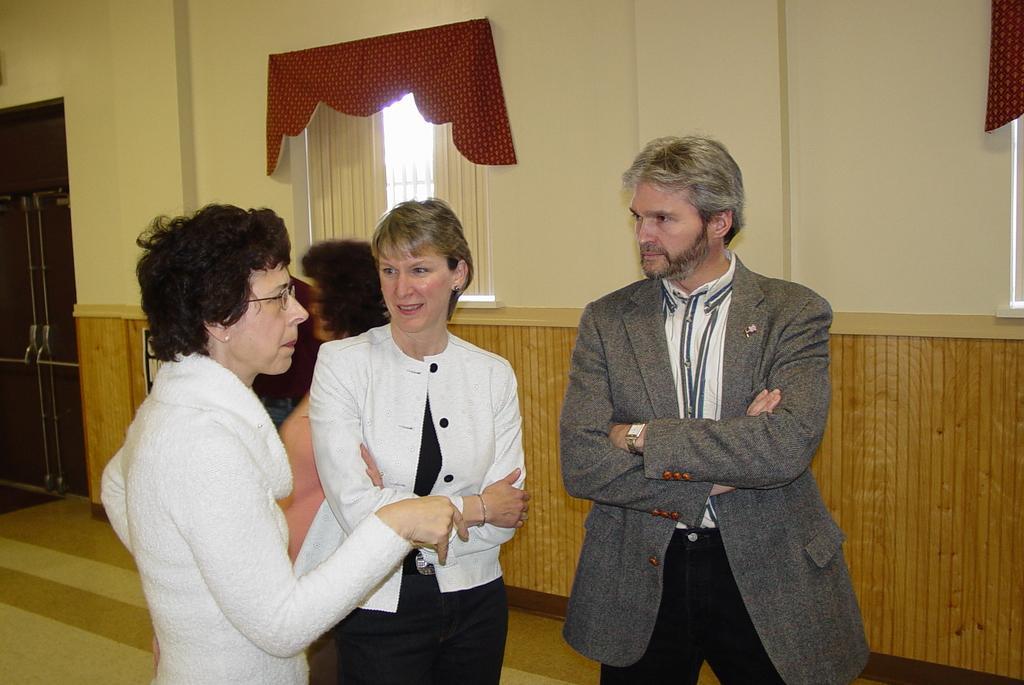Please provide a concise description of this image. In this image I can see people are standing on the floor. In the background I can see a wall which has a window, curtains and doors. The man on the right side is wearing a coat, ID card and a watch. 